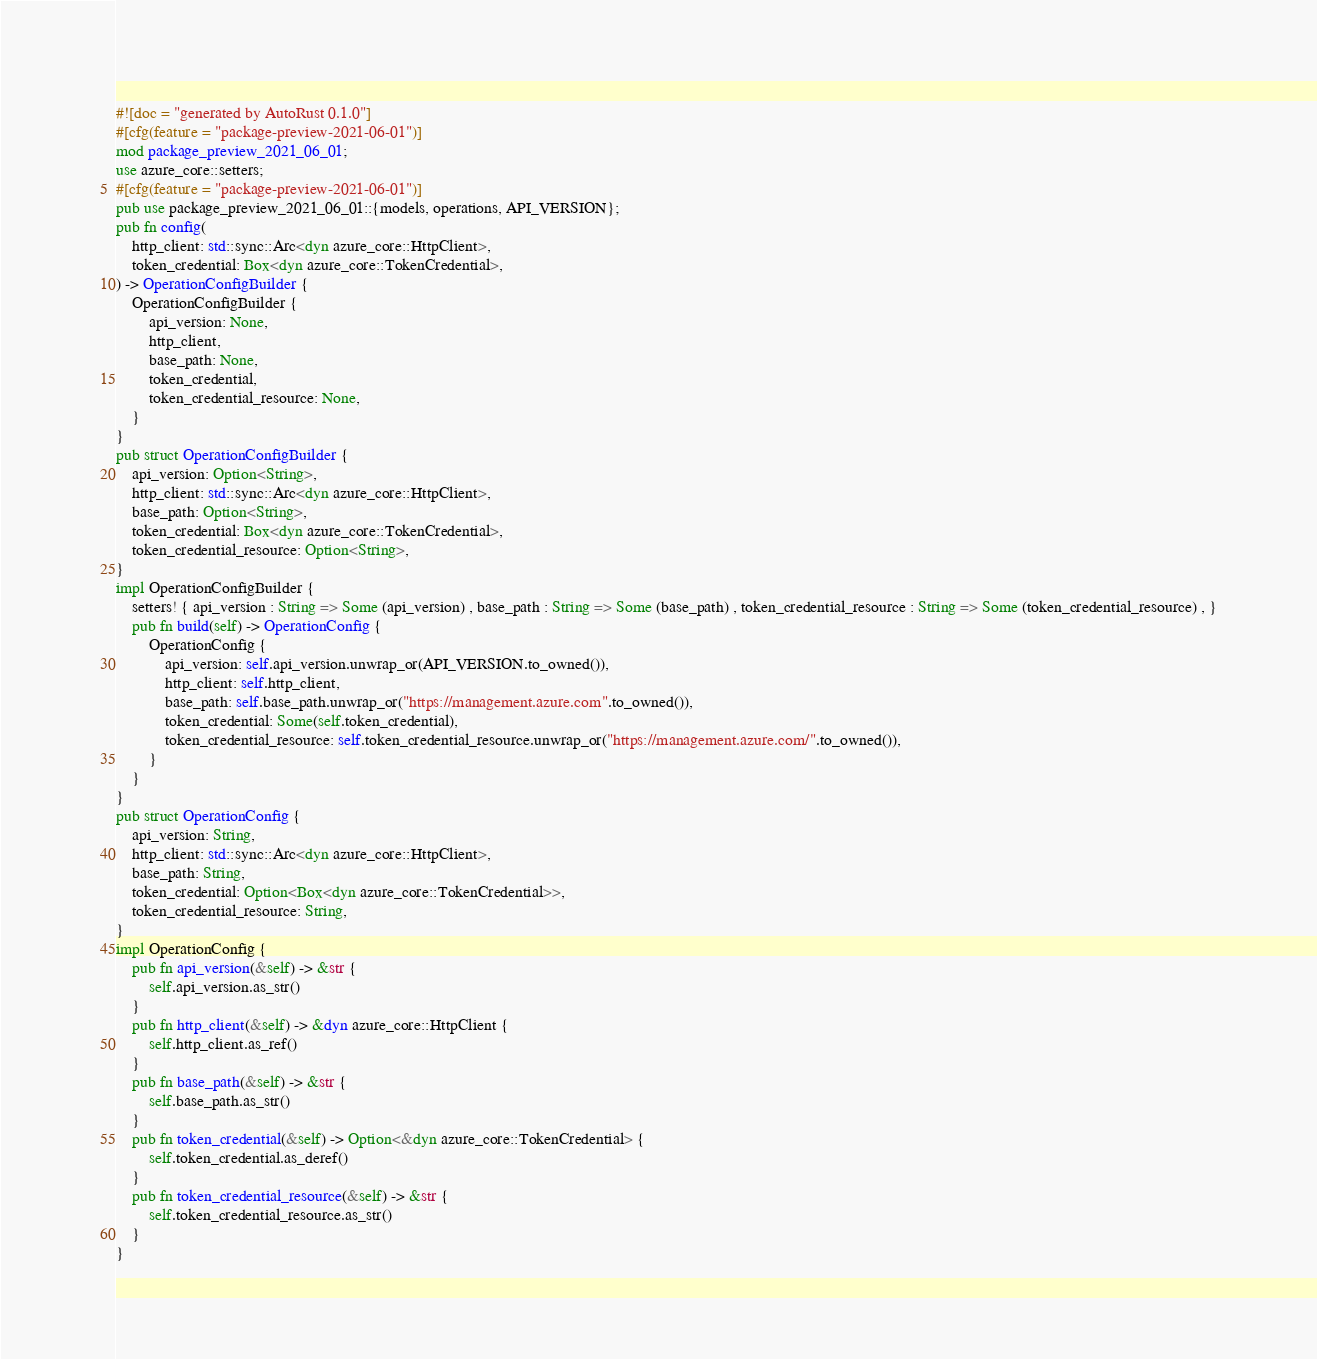<code> <loc_0><loc_0><loc_500><loc_500><_Rust_>#![doc = "generated by AutoRust 0.1.0"]
#[cfg(feature = "package-preview-2021-06-01")]
mod package_preview_2021_06_01;
use azure_core::setters;
#[cfg(feature = "package-preview-2021-06-01")]
pub use package_preview_2021_06_01::{models, operations, API_VERSION};
pub fn config(
    http_client: std::sync::Arc<dyn azure_core::HttpClient>,
    token_credential: Box<dyn azure_core::TokenCredential>,
) -> OperationConfigBuilder {
    OperationConfigBuilder {
        api_version: None,
        http_client,
        base_path: None,
        token_credential,
        token_credential_resource: None,
    }
}
pub struct OperationConfigBuilder {
    api_version: Option<String>,
    http_client: std::sync::Arc<dyn azure_core::HttpClient>,
    base_path: Option<String>,
    token_credential: Box<dyn azure_core::TokenCredential>,
    token_credential_resource: Option<String>,
}
impl OperationConfigBuilder {
    setters! { api_version : String => Some (api_version) , base_path : String => Some (base_path) , token_credential_resource : String => Some (token_credential_resource) , }
    pub fn build(self) -> OperationConfig {
        OperationConfig {
            api_version: self.api_version.unwrap_or(API_VERSION.to_owned()),
            http_client: self.http_client,
            base_path: self.base_path.unwrap_or("https://management.azure.com".to_owned()),
            token_credential: Some(self.token_credential),
            token_credential_resource: self.token_credential_resource.unwrap_or("https://management.azure.com/".to_owned()),
        }
    }
}
pub struct OperationConfig {
    api_version: String,
    http_client: std::sync::Arc<dyn azure_core::HttpClient>,
    base_path: String,
    token_credential: Option<Box<dyn azure_core::TokenCredential>>,
    token_credential_resource: String,
}
impl OperationConfig {
    pub fn api_version(&self) -> &str {
        self.api_version.as_str()
    }
    pub fn http_client(&self) -> &dyn azure_core::HttpClient {
        self.http_client.as_ref()
    }
    pub fn base_path(&self) -> &str {
        self.base_path.as_str()
    }
    pub fn token_credential(&self) -> Option<&dyn azure_core::TokenCredential> {
        self.token_credential.as_deref()
    }
    pub fn token_credential_resource(&self) -> &str {
        self.token_credential_resource.as_str()
    }
}
</code> 